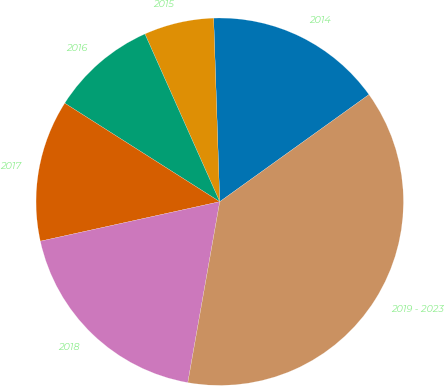Convert chart to OTSL. <chart><loc_0><loc_0><loc_500><loc_500><pie_chart><fcel>2014<fcel>2015<fcel>2016<fcel>2017<fcel>2018<fcel>2019 - 2023<nl><fcel>15.62%<fcel>6.15%<fcel>9.31%<fcel>12.46%<fcel>18.77%<fcel>37.69%<nl></chart> 